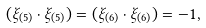Convert formula to latex. <formula><loc_0><loc_0><loc_500><loc_500>( \xi _ { ( 5 ) } \cdot \xi _ { ( 5 ) } ) = ( \xi _ { ( 6 ) } \cdot \xi _ { ( 6 ) } ) = - 1 ,</formula> 